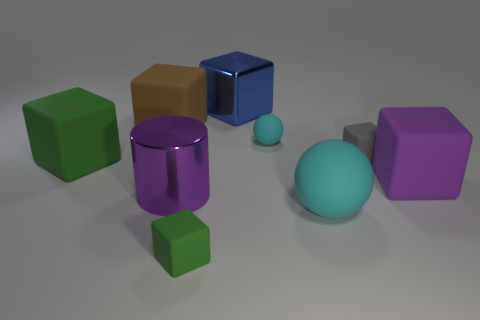I see some reflections on the objects, what does that indicate about the material or light in the scene? The reflections on the objects suggest they have a glossy finish, possibly indicating they are made of a reflective material like plastic or metal. This also implies that there is a significant light source in the scene, likely above the objects, providing the light that's reflecting. 